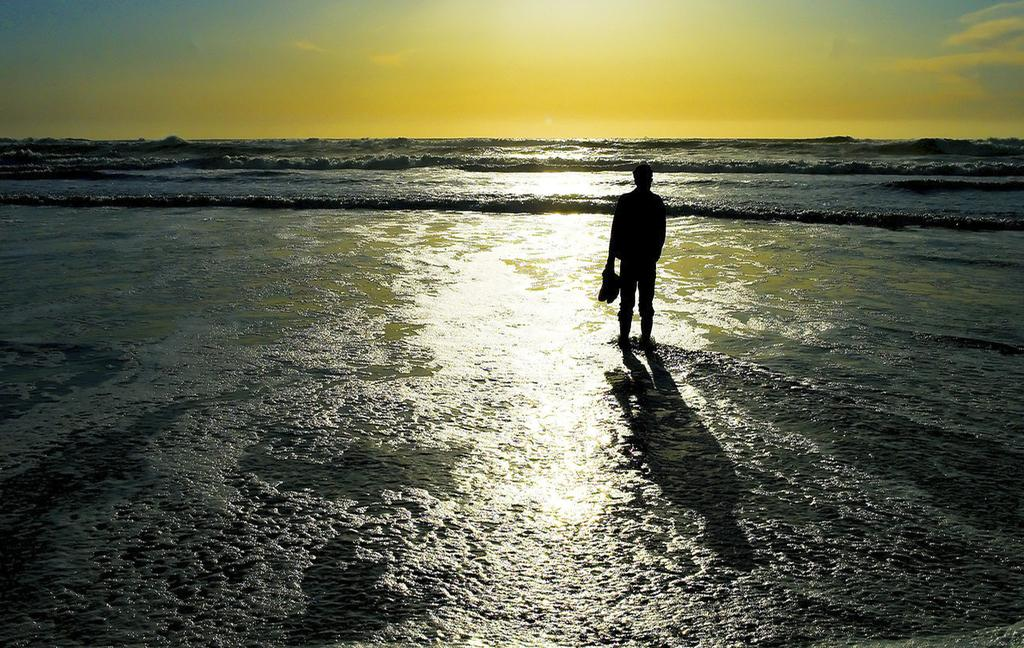What is the main subject of the image? There is a man standing in the center of the image. Can you describe the background of the image? There is water visible in the background of the image. What type of glass can be seen in the man's hand in the image? There is no glass visible in the man's hand in the image. 